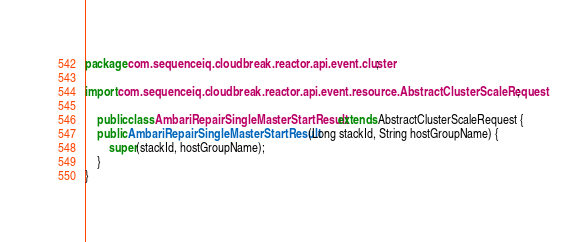<code> <loc_0><loc_0><loc_500><loc_500><_Java_>package com.sequenceiq.cloudbreak.reactor.api.event.cluster;

import com.sequenceiq.cloudbreak.reactor.api.event.resource.AbstractClusterScaleRequest;

    public class AmbariRepairSingleMasterStartResult extends AbstractClusterScaleRequest {
    public AmbariRepairSingleMasterStartResult(Long stackId, String hostGroupName) {
        super(stackId, hostGroupName);
    }
}
</code> 